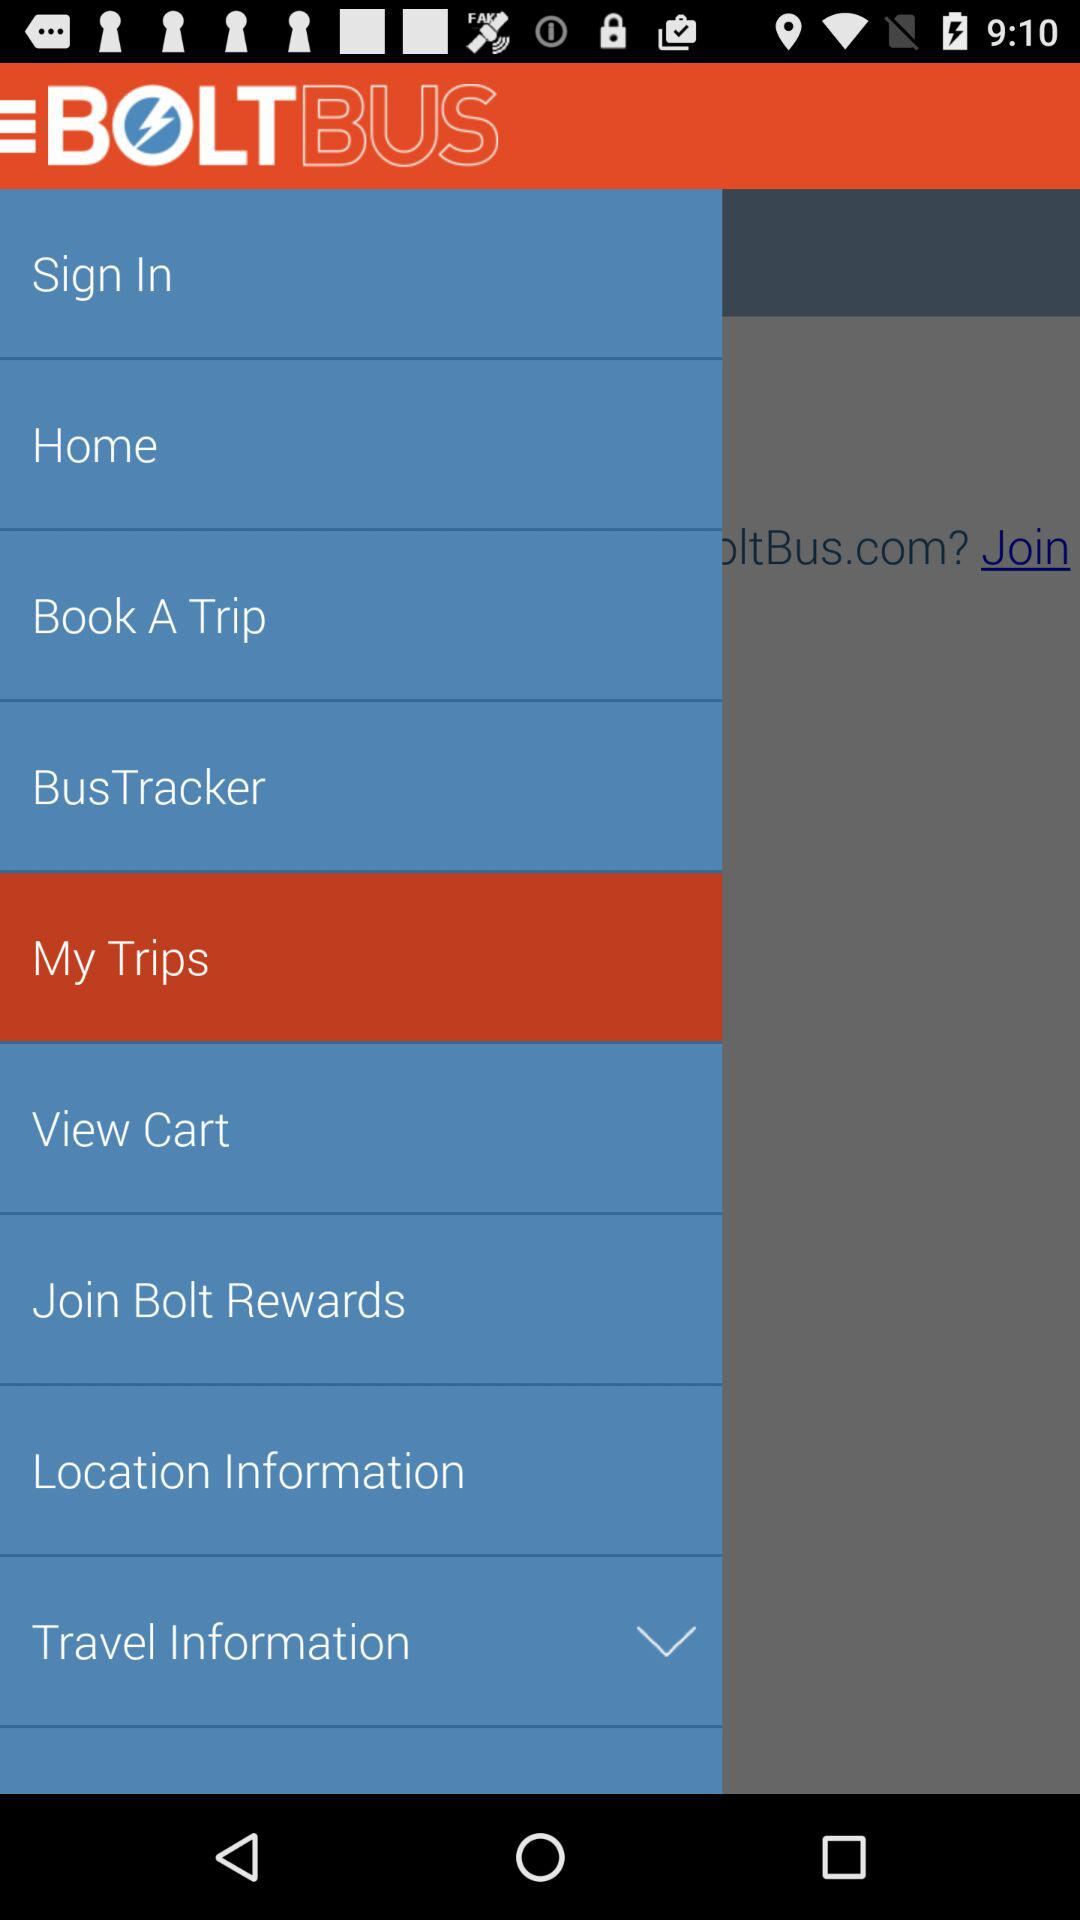What is the application name? The application name is "BOLTBUS". 